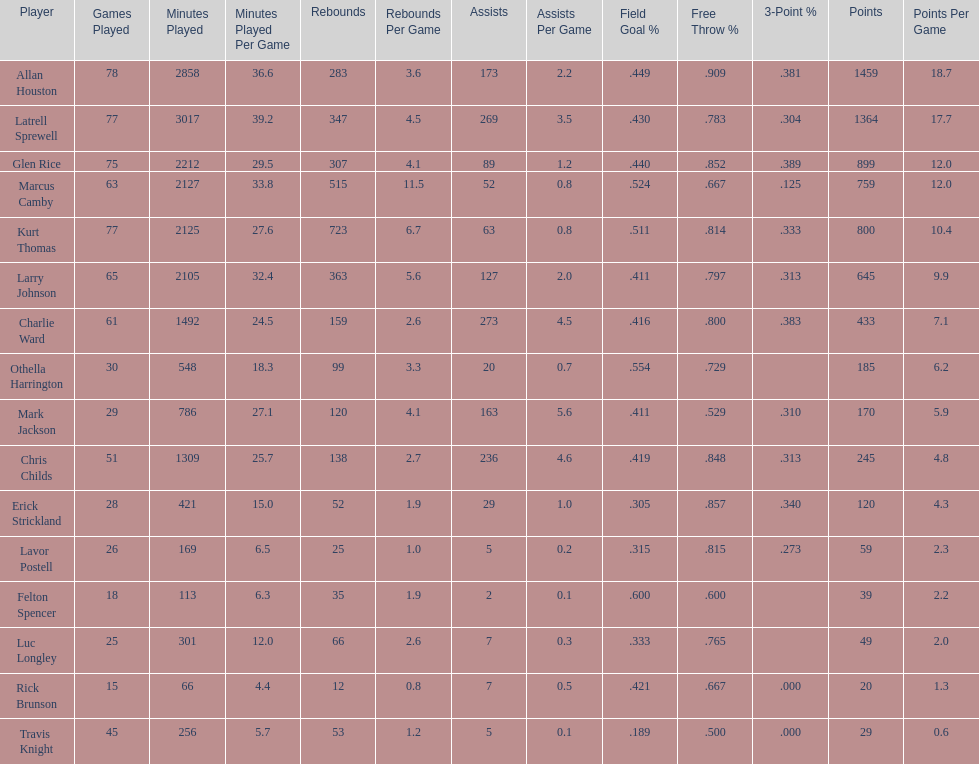What is the difference in the number of games played between allan houston and mark jackson? 49. 